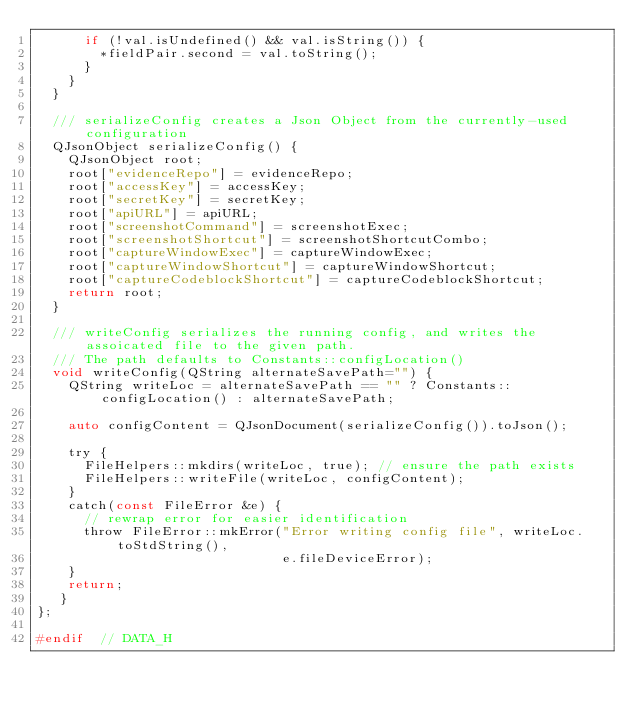<code> <loc_0><loc_0><loc_500><loc_500><_C_>      if (!val.isUndefined() && val.isString()) {
        *fieldPair.second = val.toString();
      }
    }
  }

  /// serializeConfig creates a Json Object from the currently-used configuration
  QJsonObject serializeConfig() {
    QJsonObject root;
    root["evidenceRepo"] = evidenceRepo;
    root["accessKey"] = accessKey;
    root["secretKey"] = secretKey;
    root["apiURL"] = apiURL;
    root["screenshotCommand"] = screenshotExec;
    root["screenshotShortcut"] = screenshotShortcutCombo;
    root["captureWindowExec"] = captureWindowExec;
    root["captureWindowShortcut"] = captureWindowShortcut;
    root["captureCodeblockShortcut"] = captureCodeblockShortcut;
    return root;
  }

  /// writeConfig serializes the running config, and writes the assoicated file to the given path.
  /// The path defaults to Constants::configLocation()
  void writeConfig(QString alternateSavePath="") {
    QString writeLoc = alternateSavePath == "" ? Constants::configLocation() : alternateSavePath;

    auto configContent = QJsonDocument(serializeConfig()).toJson();

    try {
      FileHelpers::mkdirs(writeLoc, true); // ensure the path exists
      FileHelpers::writeFile(writeLoc, configContent);
    }
    catch(const FileError &e) {
      // rewrap error for easier identification
      throw FileError::mkError("Error writing config file", writeLoc.toStdString(),
                               e.fileDeviceError);
    }
    return;
   }
};

#endif  // DATA_H
</code> 